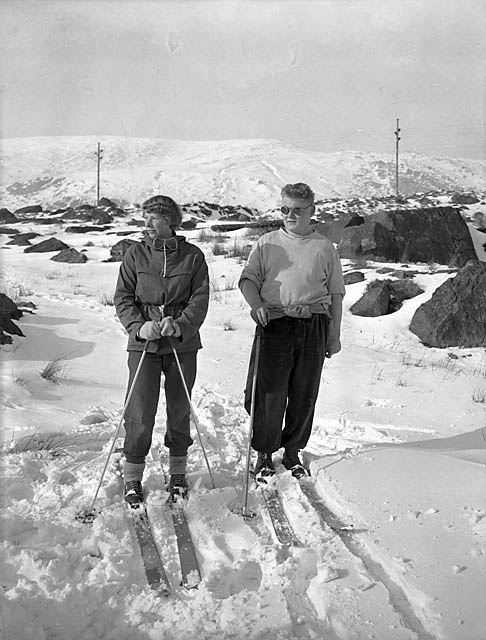Describe the objects in this image and their specific colors. I can see people in darkgray, black, gray, and lightgray tones, people in darkgray, black, gray, and lightgray tones, skis in darkgray, gray, lightgray, and black tones, and skis in darkgray, gray, lightgray, and black tones in this image. 